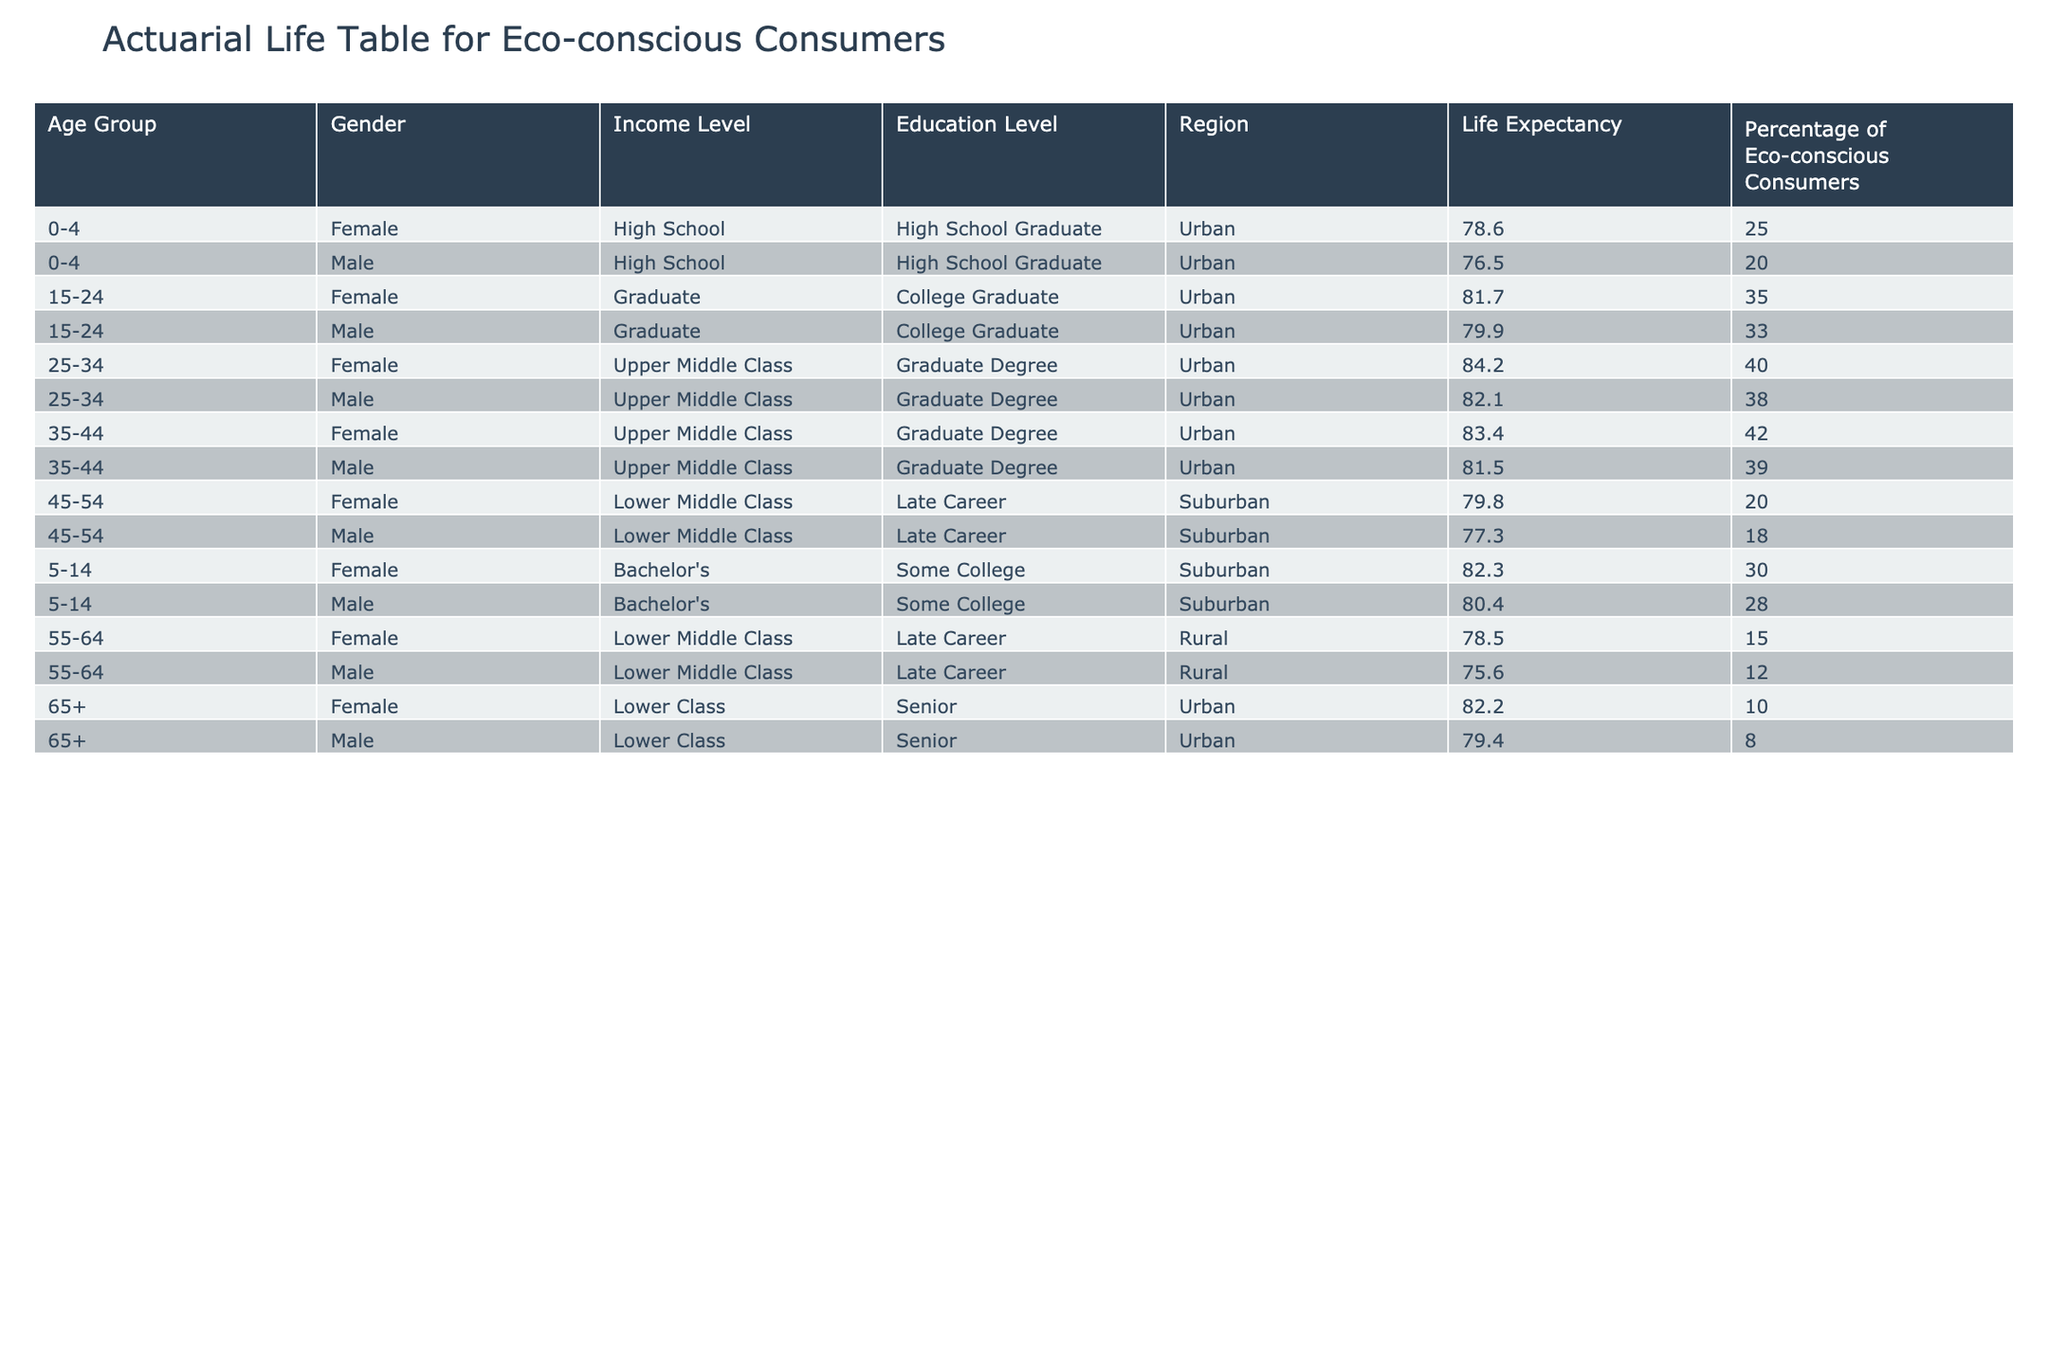What is the life expectancy for males aged 25-34? According to the table, the life expectancy for males aged 25-34 is specified in the relevant row. Referencing that row, the value is 82.1 years.
Answer: 82.1 What percentage of eco-conscious consumers are found in the age group of 55-64? Looking at the rows corresponding to the age group 55-64, we find that there is one entry for females and one for males. The percentages are 15 for females and 12 for males.
Answer: 15 for females and 12 for males Is the percentage of eco-conscious consumers higher for females or males in the “65+” age group? By examining the relevant row, the percentage for females aged 65+ is 10 and for males is 8. Comparing these values directly shows that females have a higher percentage.
Answer: Females What is the average life expectancy for eco-conscious consumers aged 15-24? For this age group, we reference both females and males. Their life expectancies are 81.7 and 79.9, respectively. Adding these gives 161.6, and dividing by 2 (the number of data points) results in an average of 80.8.
Answer: 80.8 Do lower middle-class males aged 45-54 have a longer life expectancy than lower middle-class females aged 55-64? Looking at the life expectancy for lower middle-class males aged 45-54, it is 77.3. For lower middle-class females aged 55-64, it is 78.5. Since 78.5 is greater than 77.3, we conclude that females have a longer life expectancy.
Answer: No What is the percentage difference of eco-conscious consumers between the age group 25-34 and 35-44 for females? The percentage for females aged 25-34 is 40, and for females aged 35-44 it is 42. The difference is calculated as 42 - 40 = 2.
Answer: 2 How many male eco-conscious consumers in the 0-4 age group are expected to live longer than those in the 45-54 group? The life expectancy for males in the 0-4 age group is 76.5, and in the 45-54 age group, it is 77.3. Since 76.5 is less than 77.3, no males in the 0-4 age group are expected to live longer.
Answer: No Which gender in the urban region has a higher percentage of eco-conscious consumers within the 15-24 age group? The percentage of eco-conscious consumers in that age group shows females at 35% and males at 33%. Comparing these two percentages indicates that females have the higher percentage.
Answer: Females 